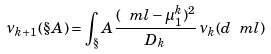Convert formula to latex. <formula><loc_0><loc_0><loc_500><loc_500>\nu _ { k + 1 } ( \S A ) = \int _ { \S } A \frac { ( \ m l - \mu _ { 1 } ^ { k } ) ^ { 2 } } { D _ { k } } \, \nu _ { k } ( d \ m l )</formula> 